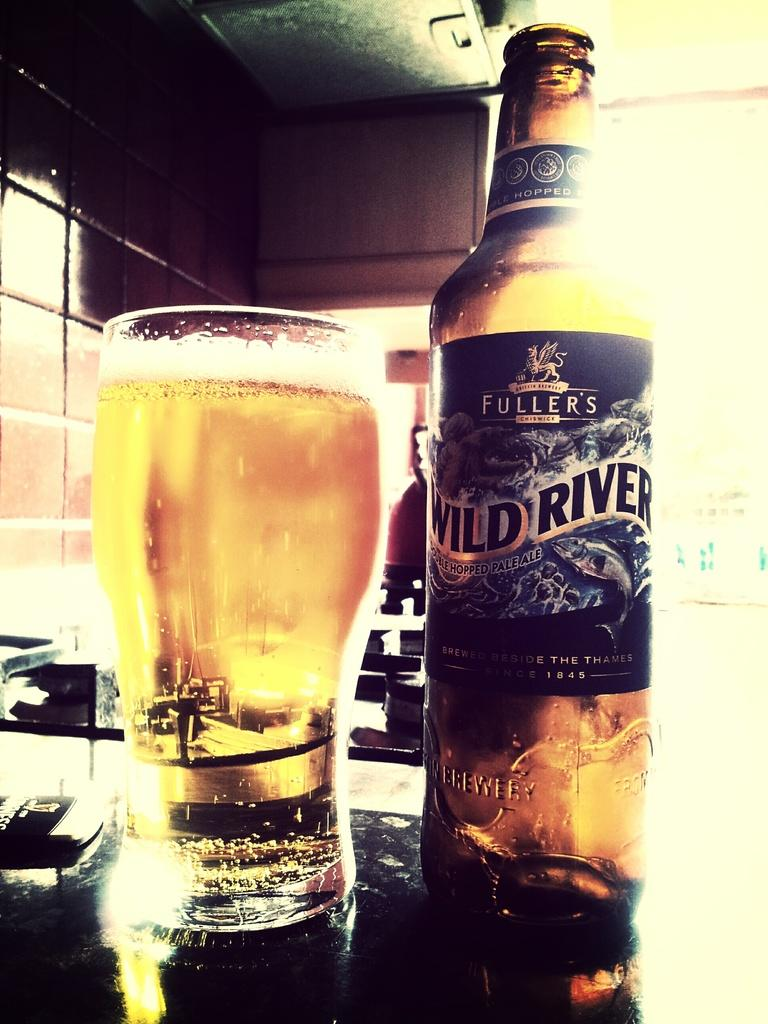What type of object can be seen in the image? There is a bottle and a drink glass in the image. What are these objects placed on? The objects are on a surface. What can be seen in the background of the image? There is a wall visible in the image. What type of car is parked next to the wall in the image? There is no car present in the image; it only features a bottle, a drink glass, and a wall. How does the iron help in the image? There is no iron present in the image, so it cannot help in any way. 